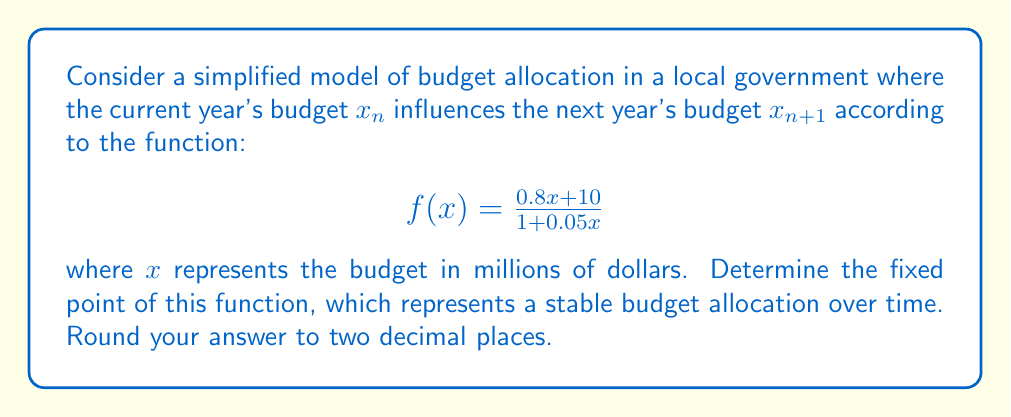Can you solve this math problem? To find the fixed point of the function, we need to solve the equation $f(x) = x$. This represents the point where the budget remains constant from one year to the next.

1) Set up the equation:
   $$x = \frac{0.8x + 10}{1 + 0.05x}$$

2) Multiply both sides by $(1 + 0.05x)$:
   $$x(1 + 0.05x) = 0.8x + 10$$

3) Expand the left side:
   $$x + 0.05x^2 = 0.8x + 10$$

4) Rearrange terms:
   $$0.05x^2 + 0.2x - 10 = 0$$

5) This is a quadratic equation. We can solve it using the quadratic formula:
   $$x = \frac{-b \pm \sqrt{b^2 - 4ac}}{2a}$$
   where $a = 0.05$, $b = 0.2$, and $c = -10$

6) Plugging in these values:
   $$x = \frac{-0.2 \pm \sqrt{0.2^2 - 4(0.05)(-10)}}{2(0.05)}$$

7) Simplify:
   $$x = \frac{-0.2 \pm \sqrt{0.04 + 2}}{0.1} = \frac{-0.2 \pm \sqrt{2.04}}{0.1}$$

8) Calculate:
   $$x = \frac{-0.2 \pm 1.4283}{0.1} = -2 \pm 14.283$$

9) This gives us two solutions: $x_1 \approx 12.283$ and $x_2 \approx -16.283$

10) Since a budget cannot be negative, we discard the negative solution.

Therefore, the fixed point of the function is approximately 12.28 million dollars.
Answer: $12.28$ million dollars 